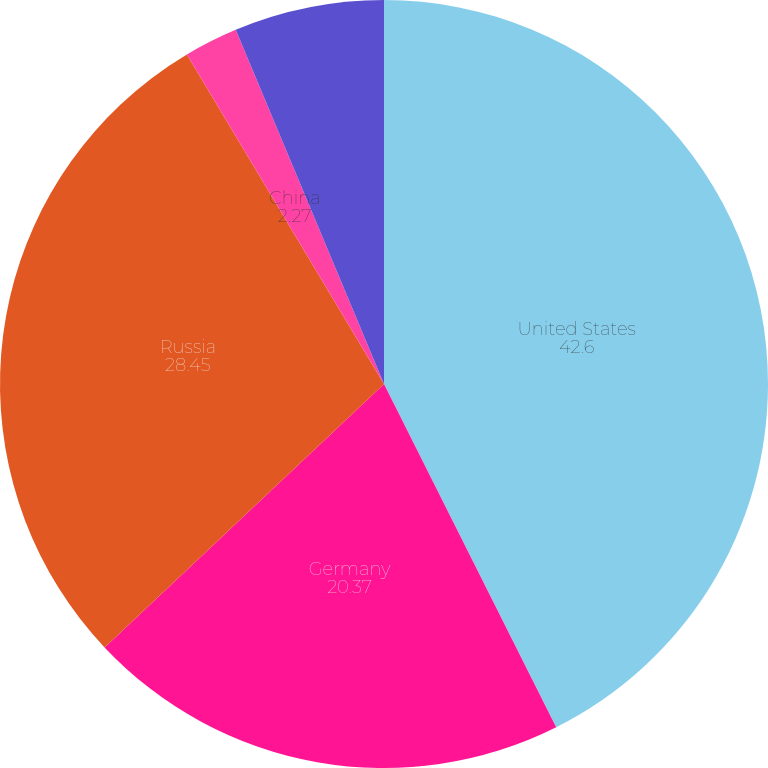<chart> <loc_0><loc_0><loc_500><loc_500><pie_chart><fcel>United States<fcel>Germany<fcel>Russia<fcel>China<fcel>Other<nl><fcel>42.6%<fcel>20.37%<fcel>28.45%<fcel>2.27%<fcel>6.31%<nl></chart> 